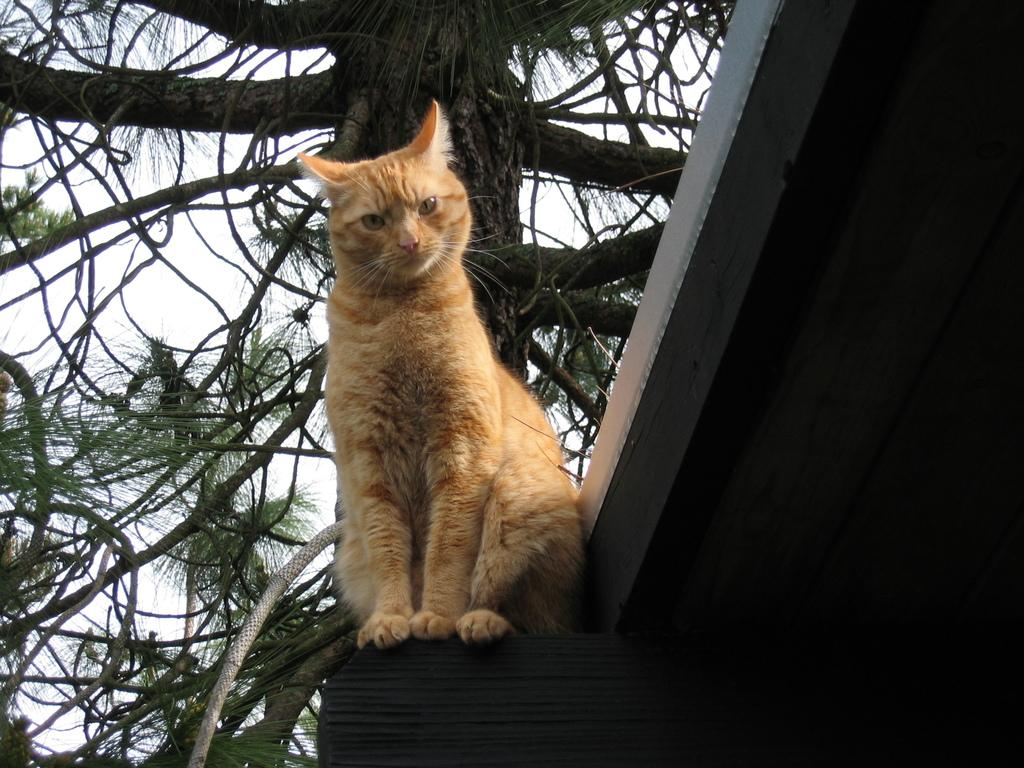What animal is present in the image? There is a cat in the image. What is the cat sitting on? The cat is sitting on a black color thing. Can you describe the color of the cat? The cat is of white and cream color. What can be seen in the background of the image? There is a tree in the background of the image. How many passengers are visible in the image? There are no passengers present in the image; it features a cat sitting on a black color thing. What type of kitten is sitting on the sweater in the image? There is no kitten or sweater present in the image; it features a cat sitting on a black color thing. 